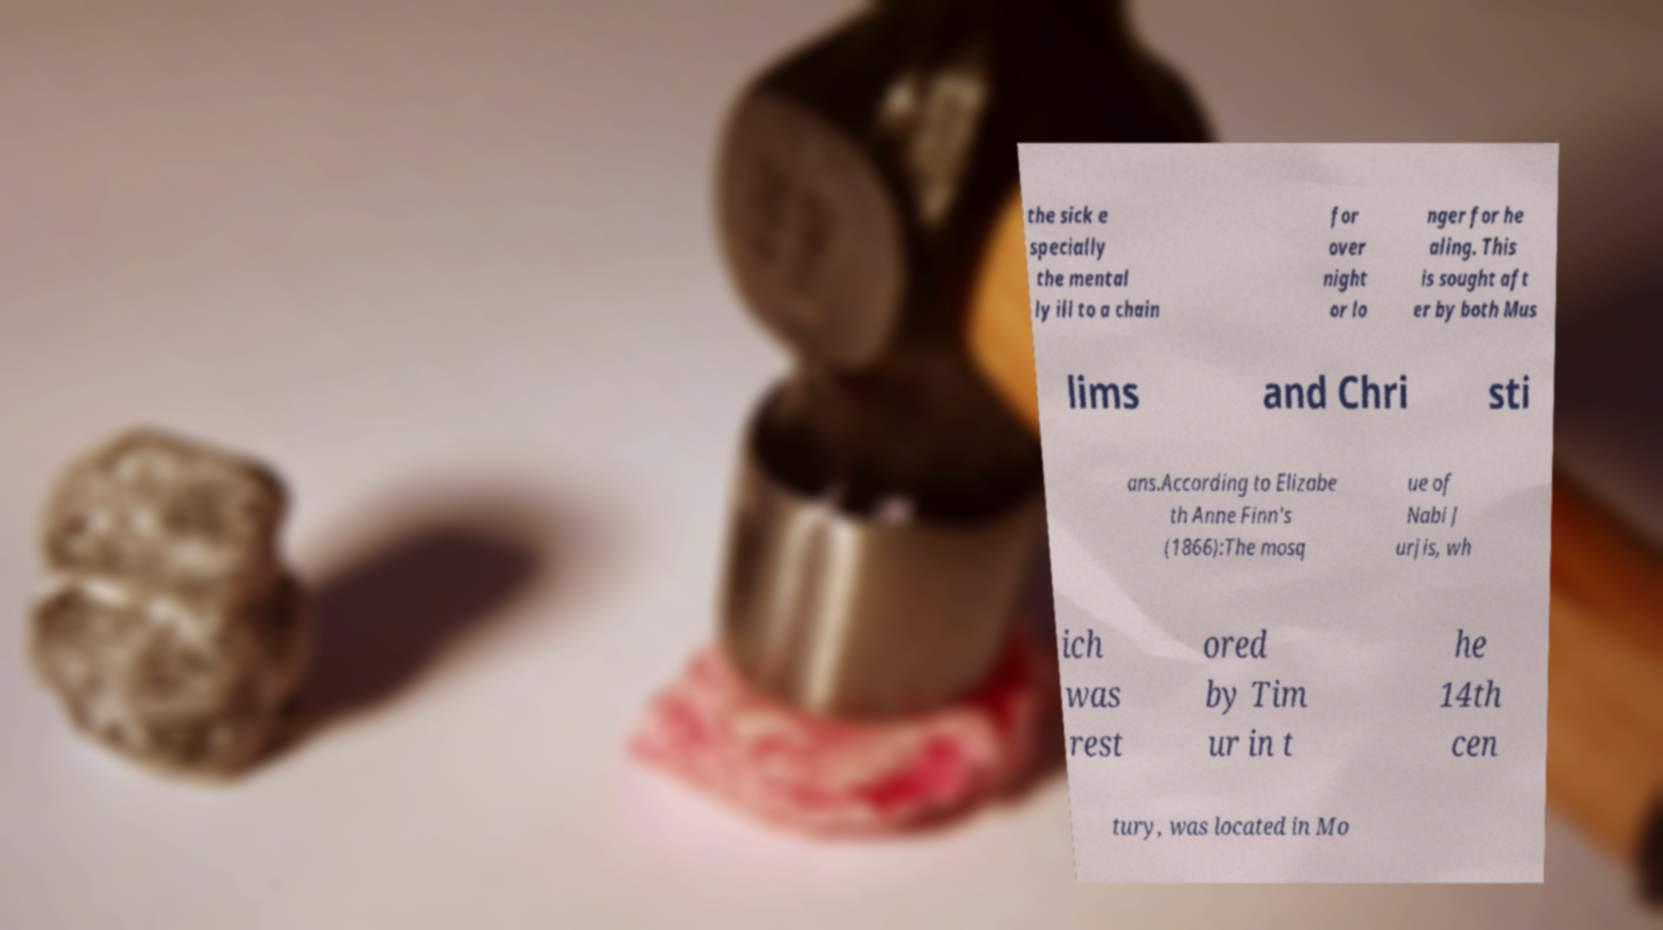Could you extract and type out the text from this image? the sick e specially the mental ly ill to a chain for over night or lo nger for he aling. This is sought aft er by both Mus lims and Chri sti ans.According to Elizabe th Anne Finn's (1866):The mosq ue of Nabi J urjis, wh ich was rest ored by Tim ur in t he 14th cen tury, was located in Mo 